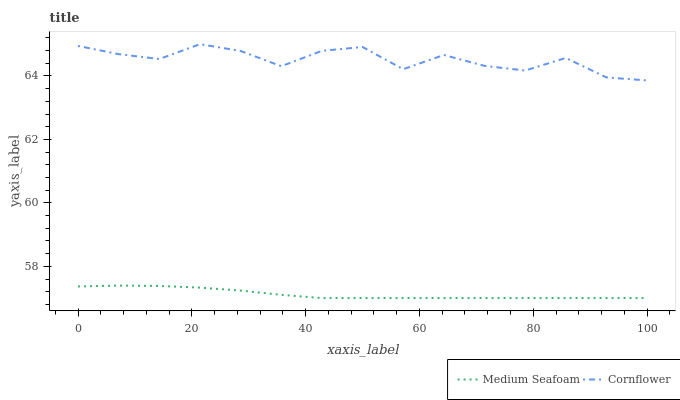Does Medium Seafoam have the minimum area under the curve?
Answer yes or no. Yes. Does Cornflower have the maximum area under the curve?
Answer yes or no. Yes. Does Medium Seafoam have the maximum area under the curve?
Answer yes or no. No. Is Medium Seafoam the smoothest?
Answer yes or no. Yes. Is Cornflower the roughest?
Answer yes or no. Yes. Is Medium Seafoam the roughest?
Answer yes or no. No. Does Medium Seafoam have the lowest value?
Answer yes or no. Yes. Does Cornflower have the highest value?
Answer yes or no. Yes. Does Medium Seafoam have the highest value?
Answer yes or no. No. Is Medium Seafoam less than Cornflower?
Answer yes or no. Yes. Is Cornflower greater than Medium Seafoam?
Answer yes or no. Yes. Does Medium Seafoam intersect Cornflower?
Answer yes or no. No. 